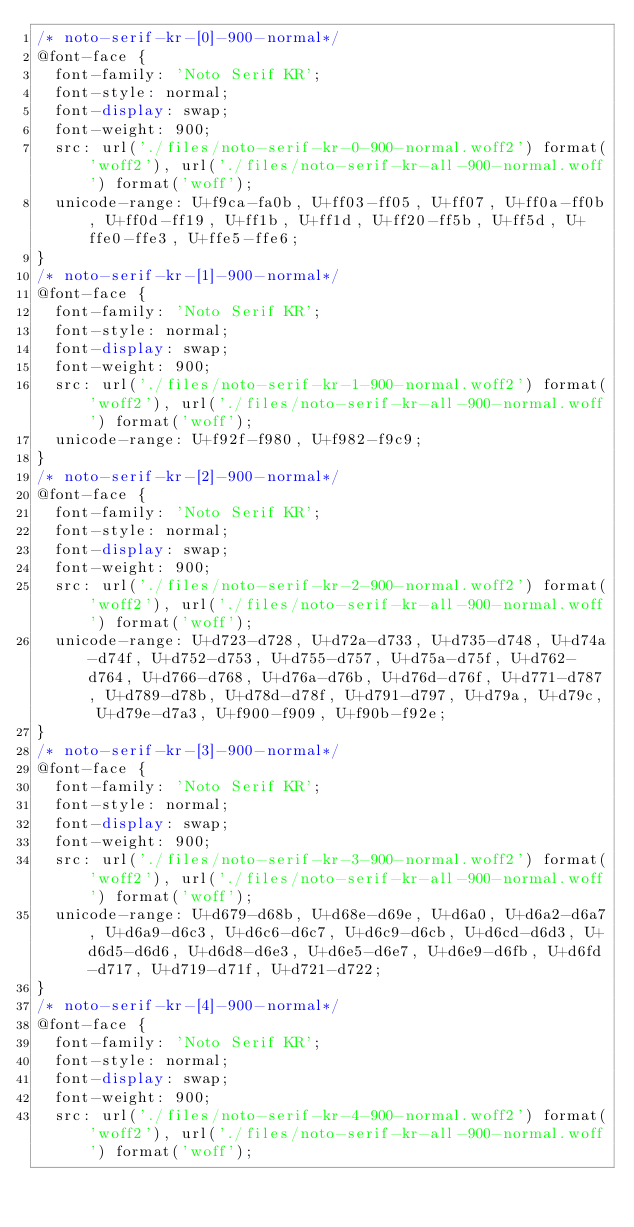Convert code to text. <code><loc_0><loc_0><loc_500><loc_500><_CSS_>/* noto-serif-kr-[0]-900-normal*/
@font-face {
  font-family: 'Noto Serif KR';
  font-style: normal;
  font-display: swap;
  font-weight: 900;
  src: url('./files/noto-serif-kr-0-900-normal.woff2') format('woff2'), url('./files/noto-serif-kr-all-900-normal.woff') format('woff');
  unicode-range: U+f9ca-fa0b, U+ff03-ff05, U+ff07, U+ff0a-ff0b, U+ff0d-ff19, U+ff1b, U+ff1d, U+ff20-ff5b, U+ff5d, U+ffe0-ffe3, U+ffe5-ffe6;
}
/* noto-serif-kr-[1]-900-normal*/
@font-face {
  font-family: 'Noto Serif KR';
  font-style: normal;
  font-display: swap;
  font-weight: 900;
  src: url('./files/noto-serif-kr-1-900-normal.woff2') format('woff2'), url('./files/noto-serif-kr-all-900-normal.woff') format('woff');
  unicode-range: U+f92f-f980, U+f982-f9c9;
}
/* noto-serif-kr-[2]-900-normal*/
@font-face {
  font-family: 'Noto Serif KR';
  font-style: normal;
  font-display: swap;
  font-weight: 900;
  src: url('./files/noto-serif-kr-2-900-normal.woff2') format('woff2'), url('./files/noto-serif-kr-all-900-normal.woff') format('woff');
  unicode-range: U+d723-d728, U+d72a-d733, U+d735-d748, U+d74a-d74f, U+d752-d753, U+d755-d757, U+d75a-d75f, U+d762-d764, U+d766-d768, U+d76a-d76b, U+d76d-d76f, U+d771-d787, U+d789-d78b, U+d78d-d78f, U+d791-d797, U+d79a, U+d79c, U+d79e-d7a3, U+f900-f909, U+f90b-f92e;
}
/* noto-serif-kr-[3]-900-normal*/
@font-face {
  font-family: 'Noto Serif KR';
  font-style: normal;
  font-display: swap;
  font-weight: 900;
  src: url('./files/noto-serif-kr-3-900-normal.woff2') format('woff2'), url('./files/noto-serif-kr-all-900-normal.woff') format('woff');
  unicode-range: U+d679-d68b, U+d68e-d69e, U+d6a0, U+d6a2-d6a7, U+d6a9-d6c3, U+d6c6-d6c7, U+d6c9-d6cb, U+d6cd-d6d3, U+d6d5-d6d6, U+d6d8-d6e3, U+d6e5-d6e7, U+d6e9-d6fb, U+d6fd-d717, U+d719-d71f, U+d721-d722;
}
/* noto-serif-kr-[4]-900-normal*/
@font-face {
  font-family: 'Noto Serif KR';
  font-style: normal;
  font-display: swap;
  font-weight: 900;
  src: url('./files/noto-serif-kr-4-900-normal.woff2') format('woff2'), url('./files/noto-serif-kr-all-900-normal.woff') format('woff');</code> 